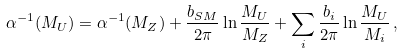Convert formula to latex. <formula><loc_0><loc_0><loc_500><loc_500>\alpha ^ { - 1 } ( M _ { U } ) = \alpha ^ { - 1 } ( M _ { Z } ) + \frac { b _ { S M } } { 2 \pi } \ln \frac { M _ { U } } { M _ { Z } } + \sum _ { i } \frac { b _ { i } } { 2 \pi } \ln \frac { M _ { U } } { M _ { i } } \, ,</formula> 